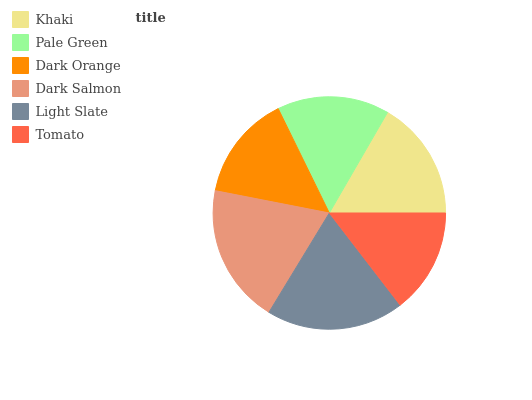Is Tomato the minimum?
Answer yes or no. Yes. Is Dark Salmon the maximum?
Answer yes or no. Yes. Is Pale Green the minimum?
Answer yes or no. No. Is Pale Green the maximum?
Answer yes or no. No. Is Khaki greater than Pale Green?
Answer yes or no. Yes. Is Pale Green less than Khaki?
Answer yes or no. Yes. Is Pale Green greater than Khaki?
Answer yes or no. No. Is Khaki less than Pale Green?
Answer yes or no. No. Is Khaki the high median?
Answer yes or no. Yes. Is Pale Green the low median?
Answer yes or no. Yes. Is Pale Green the high median?
Answer yes or no. No. Is Light Slate the low median?
Answer yes or no. No. 